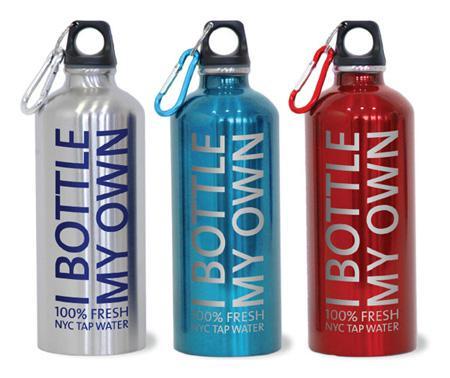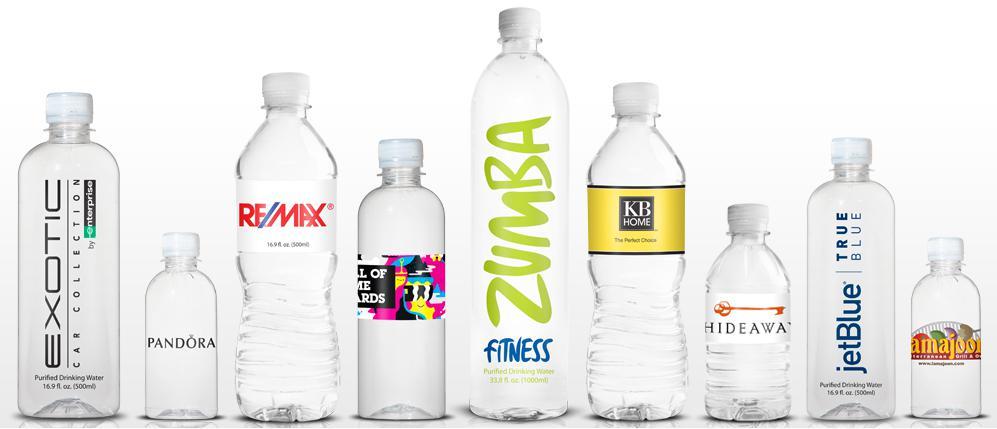The first image is the image on the left, the second image is the image on the right. Evaluate the accuracy of this statement regarding the images: "One image contains exactly two bottles displayed level and head-on, and the other image includes at least four identical bottles with identical labels.". Is it true? Answer yes or no. No. The first image is the image on the left, the second image is the image on the right. Assess this claim about the two images: "The left and right image contains a total of six bottles.". Correct or not? Answer yes or no. No. 